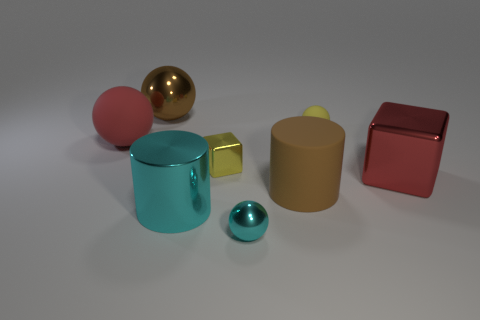The shiny object that is the same color as the large shiny cylinder is what shape?
Provide a short and direct response. Sphere. What is the thing that is both right of the small cyan sphere and behind the big red sphere made of?
Keep it short and to the point. Rubber. There is a big red metal object; is it the same shape as the brown thing left of the shiny cylinder?
Ensure brevity in your answer.  No. How many other things are the same size as the brown matte object?
Offer a terse response. 4. Are there more large blue metal spheres than tiny matte objects?
Ensure brevity in your answer.  No. What number of metal objects are on the left side of the yellow ball and in front of the yellow shiny thing?
Your answer should be compact. 2. What shape is the big brown object in front of the rubber sphere that is right of the shiny sphere that is in front of the large red metal block?
Your answer should be compact. Cylinder. Is there any other thing that is the same shape as the big cyan object?
Give a very brief answer. Yes. How many cylinders are either tiny rubber objects or tiny yellow shiny things?
Give a very brief answer. 0. Do the large matte object that is left of the cyan cylinder and the big shiny block have the same color?
Give a very brief answer. Yes. 